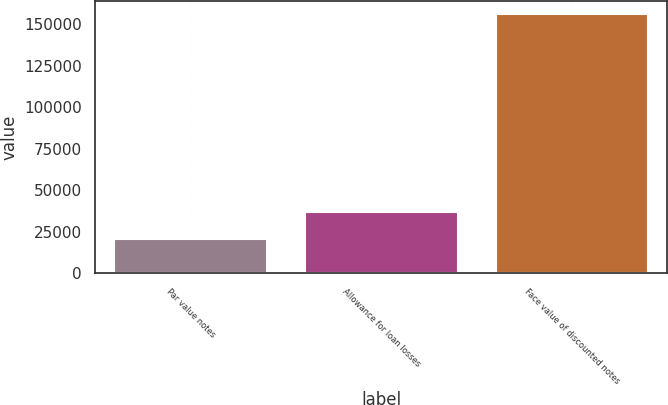Convert chart to OTSL. <chart><loc_0><loc_0><loc_500><loc_500><bar_chart><fcel>Par value notes<fcel>Allowance for loan losses<fcel>Face value of discounted notes<nl><fcel>20862<fcel>37061<fcel>155848<nl></chart> 